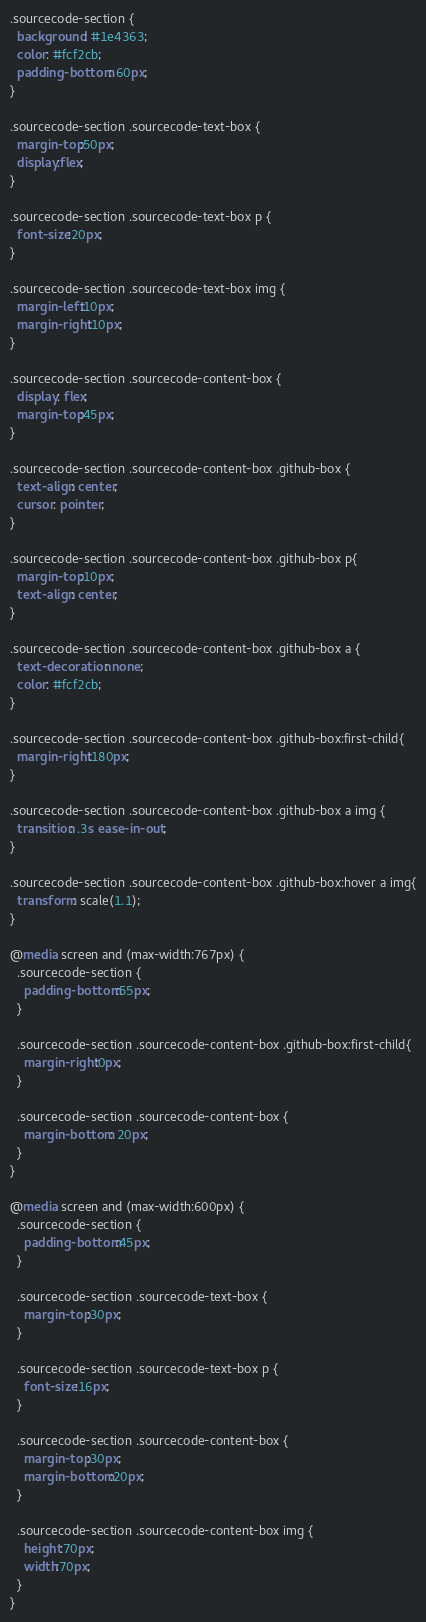<code> <loc_0><loc_0><loc_500><loc_500><_CSS_>.sourcecode-section {
  background: #1e4363;
  color: #fcf2cb;
  padding-bottom: 60px;
}

.sourcecode-section .sourcecode-text-box {
  margin-top:50px;
  display:flex;
}

.sourcecode-section .sourcecode-text-box p {
  font-size:20px;
}

.sourcecode-section .sourcecode-text-box img {
  margin-left:10px;
  margin-right:10px;
}

.sourcecode-section .sourcecode-content-box {
  display: flex;
  margin-top:45px;
}

.sourcecode-section .sourcecode-content-box .github-box {
  text-align: center;
  cursor: pointer;
}

.sourcecode-section .sourcecode-content-box .github-box p{
  margin-top:10px;
  text-align: center;
}

.sourcecode-section .sourcecode-content-box .github-box a {
  text-decoration: none;
  color: #fcf2cb;
}

.sourcecode-section .sourcecode-content-box .github-box:first-child{
  margin-right:180px;
}

.sourcecode-section .sourcecode-content-box .github-box a img {
  transition: .3s ease-in-out;
}

.sourcecode-section .sourcecode-content-box .github-box:hover a img{
  transform: scale(1.1);
}

@media screen and (max-width:767px) {
  .sourcecode-section {
    padding-bottom:55px;
  }

  .sourcecode-section .sourcecode-content-box .github-box:first-child{
    margin-right:0px;
  }

  .sourcecode-section .sourcecode-content-box {
    margin-bottom: 20px;
  }
}

@media screen and (max-width:600px) {
  .sourcecode-section {
    padding-bottom:45px;
  }
  
  .sourcecode-section .sourcecode-text-box {
    margin-top:30px;
  }

  .sourcecode-section .sourcecode-text-box p {
    font-size:16px;
  }

  .sourcecode-section .sourcecode-content-box {
    margin-top:30px;
    margin-bottom:20px;
  }

  .sourcecode-section .sourcecode-content-box img {
    height:70px;
    width:70px;
  }
}

</code> 